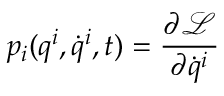<formula> <loc_0><loc_0><loc_500><loc_500>p _ { i } ( q ^ { i } , { \dot { q } } ^ { i } , t ) = { \frac { \partial { \mathcal { L } } } { \partial { \dot { q } } ^ { i } } }</formula> 